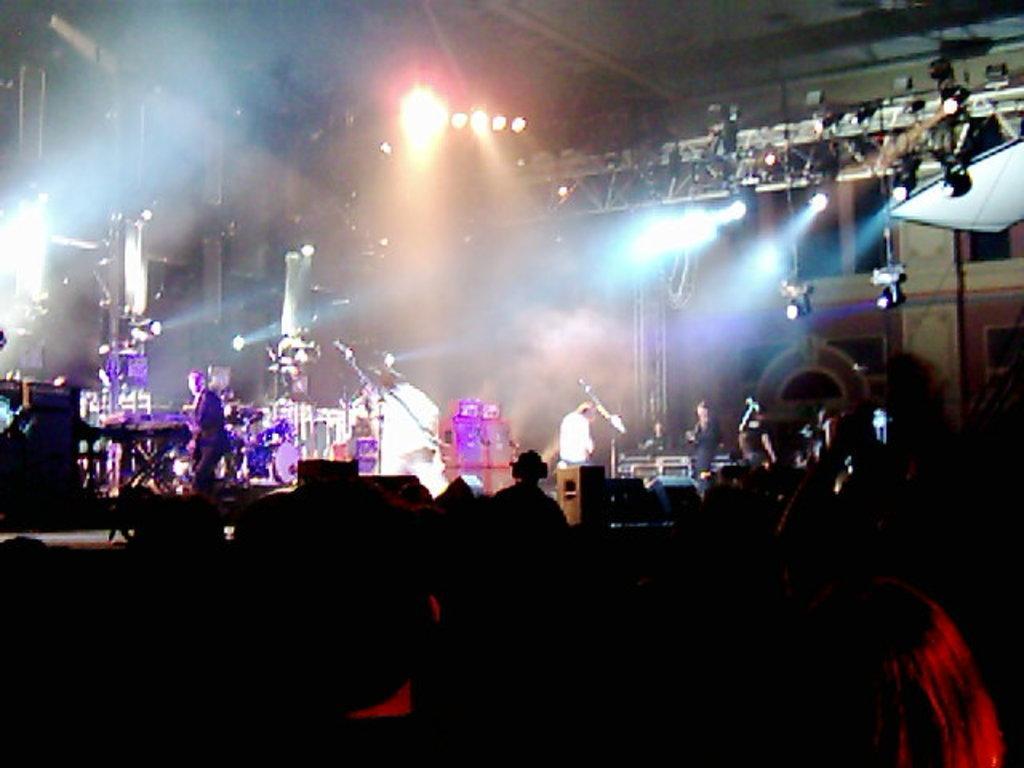Can you describe this image briefly? In this image I can see few people, musical instruments, lights, poles and few objects around. The image is dark. 